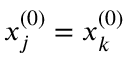Convert formula to latex. <formula><loc_0><loc_0><loc_500><loc_500>x _ { j } ^ { ( 0 ) } = x _ { k } ^ { ( 0 ) }</formula> 